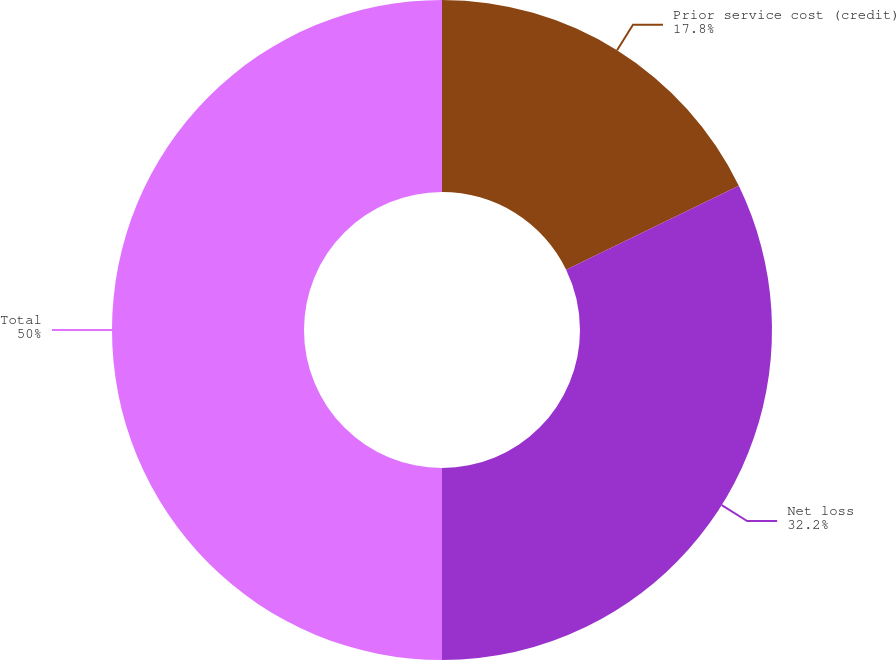<chart> <loc_0><loc_0><loc_500><loc_500><pie_chart><fcel>Prior service cost (credit)<fcel>Net loss<fcel>Total<nl><fcel>17.8%<fcel>32.2%<fcel>50.0%<nl></chart> 